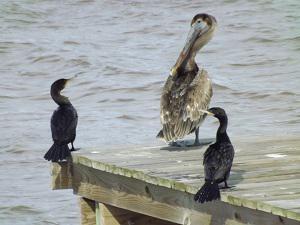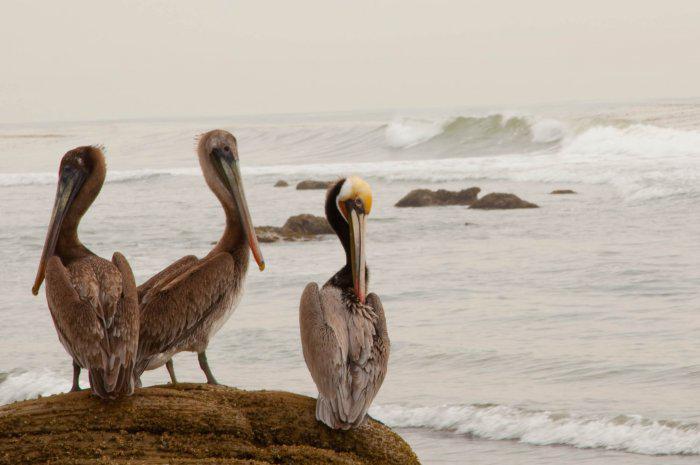The first image is the image on the left, the second image is the image on the right. Examine the images to the left and right. Is the description "Three birds in the image on the left are standing on a manmade object near the water." accurate? Answer yes or no. Yes. 